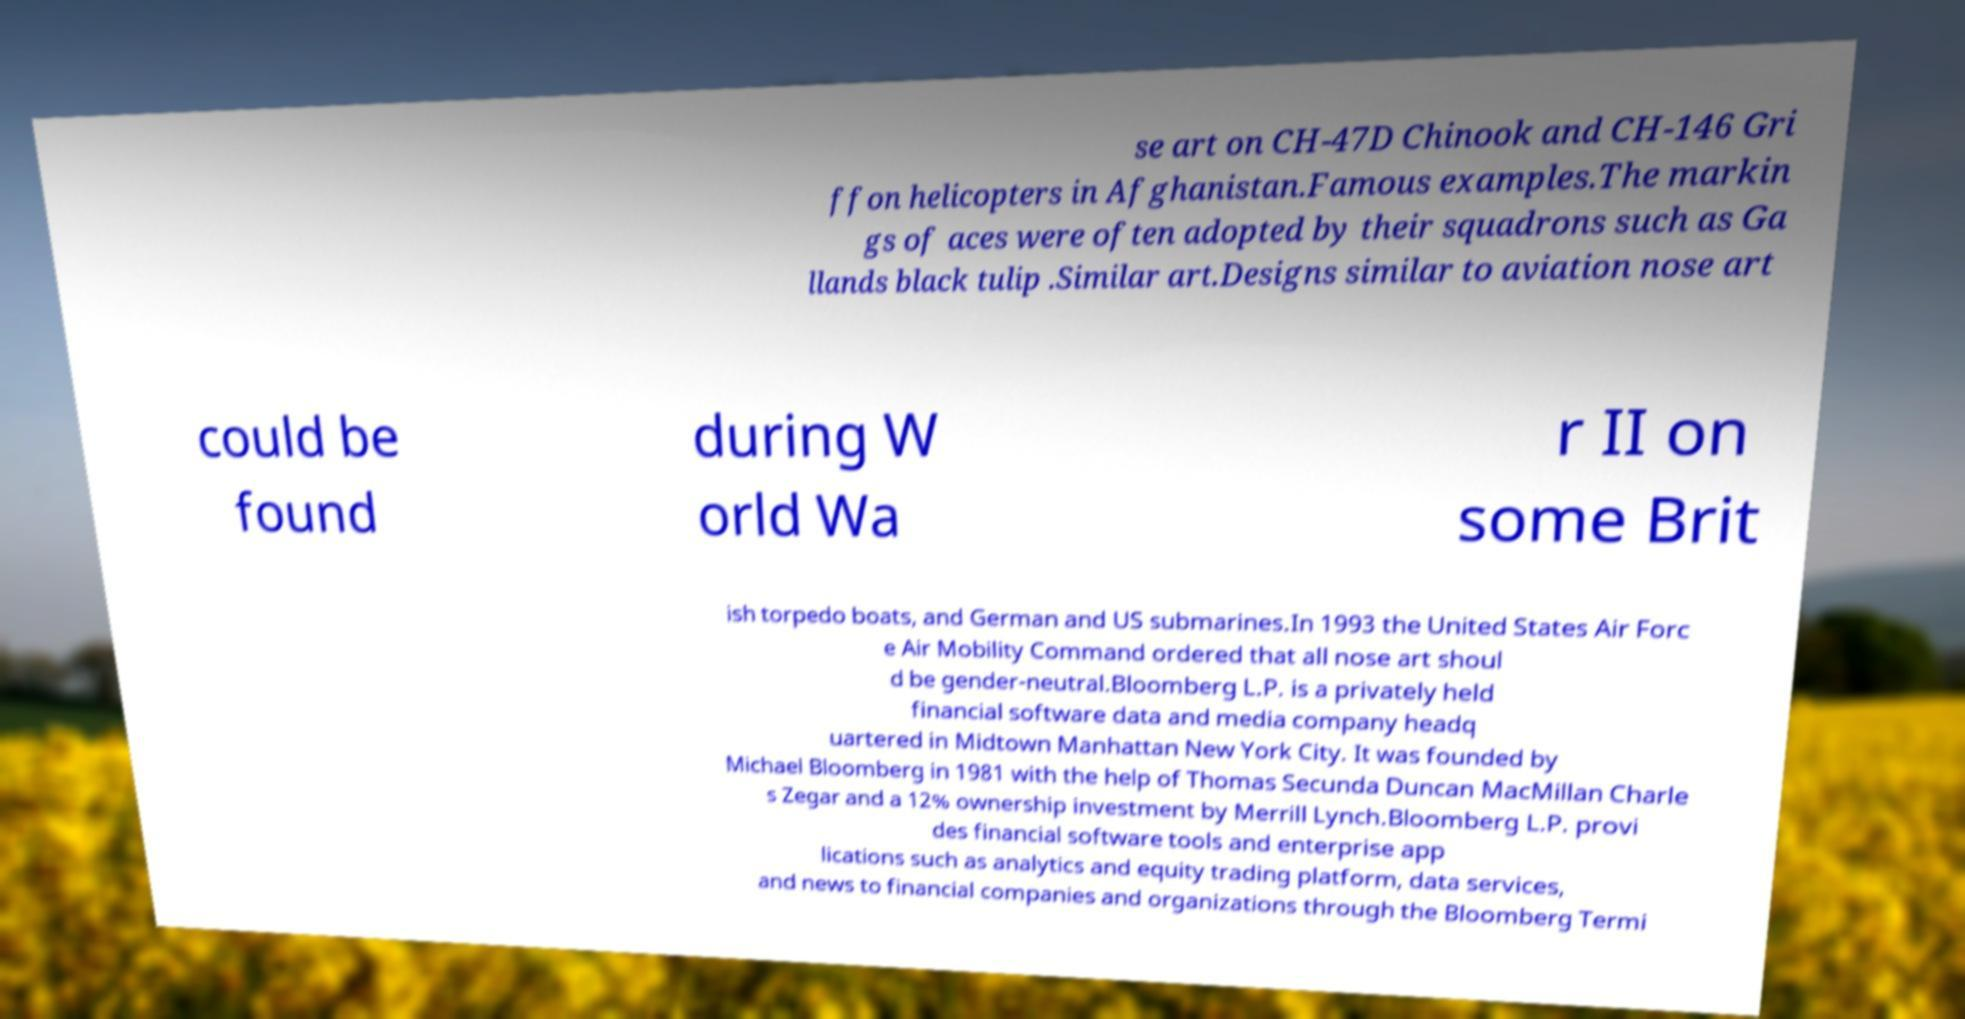What messages or text are displayed in this image? I need them in a readable, typed format. se art on CH-47D Chinook and CH-146 Gri ffon helicopters in Afghanistan.Famous examples.The markin gs of aces were often adopted by their squadrons such as Ga llands black tulip .Similar art.Designs similar to aviation nose art could be found during W orld Wa r II on some Brit ish torpedo boats, and German and US submarines.In 1993 the United States Air Forc e Air Mobility Command ordered that all nose art shoul d be gender-neutral.Bloomberg L.P. is a privately held financial software data and media company headq uartered in Midtown Manhattan New York City. It was founded by Michael Bloomberg in 1981 with the help of Thomas Secunda Duncan MacMillan Charle s Zegar and a 12% ownership investment by Merrill Lynch.Bloomberg L.P. provi des financial software tools and enterprise app lications such as analytics and equity trading platform, data services, and news to financial companies and organizations through the Bloomberg Termi 